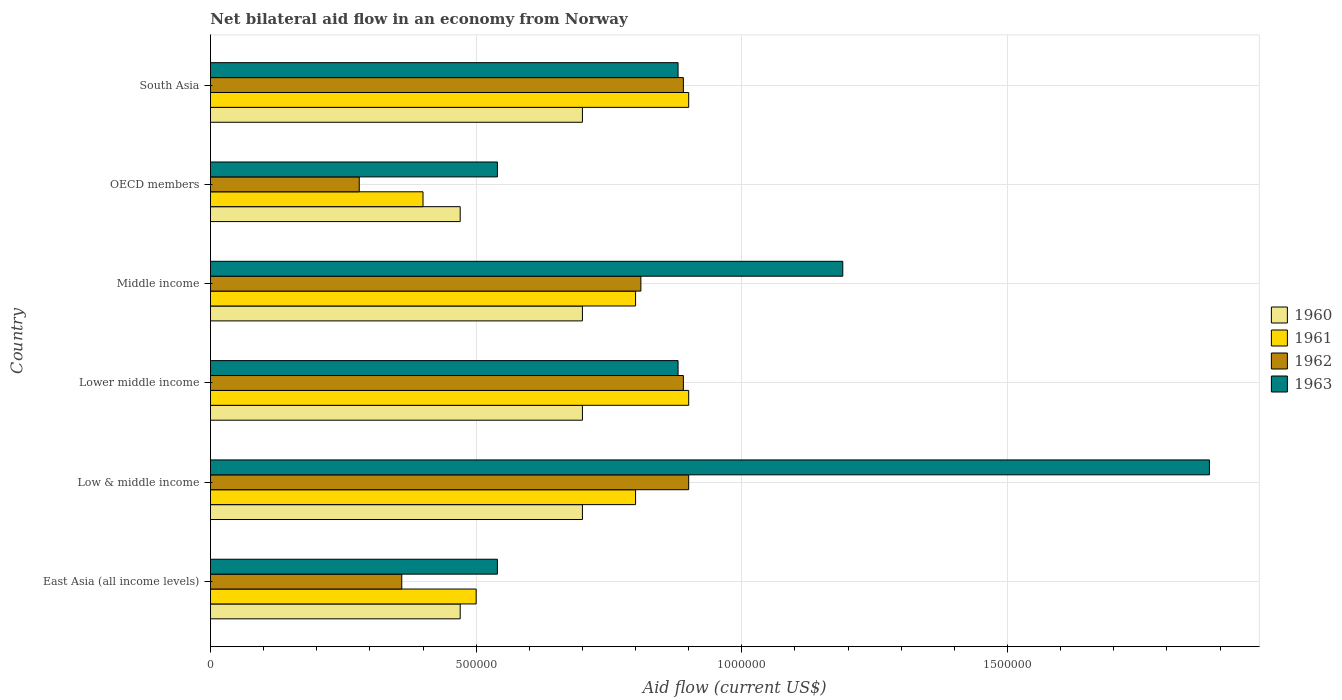How many groups of bars are there?
Offer a very short reply. 6. Are the number of bars on each tick of the Y-axis equal?
Provide a succinct answer. Yes. How many bars are there on the 2nd tick from the top?
Your response must be concise. 4. What is the label of the 4th group of bars from the top?
Your answer should be very brief. Lower middle income. What is the net bilateral aid flow in 1960 in OECD members?
Give a very brief answer. 4.70e+05. In which country was the net bilateral aid flow in 1960 minimum?
Your answer should be very brief. East Asia (all income levels). What is the total net bilateral aid flow in 1962 in the graph?
Offer a very short reply. 4.13e+06. What is the difference between the net bilateral aid flow in 1963 in South Asia and the net bilateral aid flow in 1962 in OECD members?
Offer a very short reply. 6.00e+05. What is the average net bilateral aid flow in 1961 per country?
Ensure brevity in your answer.  7.17e+05. What is the difference between the net bilateral aid flow in 1962 and net bilateral aid flow in 1961 in South Asia?
Ensure brevity in your answer.  -10000. In how many countries, is the net bilateral aid flow in 1960 greater than 800000 US$?
Keep it short and to the point. 0. What is the ratio of the net bilateral aid flow in 1962 in East Asia (all income levels) to that in OECD members?
Ensure brevity in your answer.  1.29. Is the net bilateral aid flow in 1961 in Middle income less than that in OECD members?
Offer a very short reply. No. Is the difference between the net bilateral aid flow in 1962 in Low & middle income and Middle income greater than the difference between the net bilateral aid flow in 1961 in Low & middle income and Middle income?
Give a very brief answer. Yes. What is the difference between the highest and the lowest net bilateral aid flow in 1961?
Give a very brief answer. 5.00e+05. Is the sum of the net bilateral aid flow in 1962 in Middle income and OECD members greater than the maximum net bilateral aid flow in 1960 across all countries?
Offer a very short reply. Yes. Is it the case that in every country, the sum of the net bilateral aid flow in 1960 and net bilateral aid flow in 1963 is greater than the sum of net bilateral aid flow in 1962 and net bilateral aid flow in 1961?
Keep it short and to the point. No. How many bars are there?
Provide a succinct answer. 24. Are all the bars in the graph horizontal?
Give a very brief answer. Yes. What is the difference between two consecutive major ticks on the X-axis?
Keep it short and to the point. 5.00e+05. Are the values on the major ticks of X-axis written in scientific E-notation?
Your response must be concise. No. Does the graph contain grids?
Offer a terse response. Yes. Where does the legend appear in the graph?
Offer a terse response. Center right. What is the title of the graph?
Provide a succinct answer. Net bilateral aid flow in an economy from Norway. Does "1966" appear as one of the legend labels in the graph?
Offer a terse response. No. What is the label or title of the X-axis?
Offer a very short reply. Aid flow (current US$). What is the Aid flow (current US$) in 1960 in East Asia (all income levels)?
Keep it short and to the point. 4.70e+05. What is the Aid flow (current US$) of 1961 in East Asia (all income levels)?
Ensure brevity in your answer.  5.00e+05. What is the Aid flow (current US$) in 1962 in East Asia (all income levels)?
Offer a very short reply. 3.60e+05. What is the Aid flow (current US$) in 1963 in East Asia (all income levels)?
Offer a very short reply. 5.40e+05. What is the Aid flow (current US$) of 1962 in Low & middle income?
Your answer should be very brief. 9.00e+05. What is the Aid flow (current US$) of 1963 in Low & middle income?
Give a very brief answer. 1.88e+06. What is the Aid flow (current US$) in 1962 in Lower middle income?
Offer a terse response. 8.90e+05. What is the Aid flow (current US$) in 1963 in Lower middle income?
Give a very brief answer. 8.80e+05. What is the Aid flow (current US$) of 1960 in Middle income?
Ensure brevity in your answer.  7.00e+05. What is the Aid flow (current US$) in 1962 in Middle income?
Keep it short and to the point. 8.10e+05. What is the Aid flow (current US$) in 1963 in Middle income?
Your response must be concise. 1.19e+06. What is the Aid flow (current US$) of 1960 in OECD members?
Offer a terse response. 4.70e+05. What is the Aid flow (current US$) of 1963 in OECD members?
Offer a terse response. 5.40e+05. What is the Aid flow (current US$) in 1960 in South Asia?
Ensure brevity in your answer.  7.00e+05. What is the Aid flow (current US$) in 1961 in South Asia?
Your response must be concise. 9.00e+05. What is the Aid flow (current US$) of 1962 in South Asia?
Give a very brief answer. 8.90e+05. What is the Aid flow (current US$) of 1963 in South Asia?
Your response must be concise. 8.80e+05. Across all countries, what is the maximum Aid flow (current US$) of 1962?
Ensure brevity in your answer.  9.00e+05. Across all countries, what is the maximum Aid flow (current US$) in 1963?
Your response must be concise. 1.88e+06. Across all countries, what is the minimum Aid flow (current US$) in 1960?
Provide a short and direct response. 4.70e+05. Across all countries, what is the minimum Aid flow (current US$) in 1961?
Make the answer very short. 4.00e+05. Across all countries, what is the minimum Aid flow (current US$) in 1962?
Ensure brevity in your answer.  2.80e+05. Across all countries, what is the minimum Aid flow (current US$) in 1963?
Offer a terse response. 5.40e+05. What is the total Aid flow (current US$) in 1960 in the graph?
Make the answer very short. 3.74e+06. What is the total Aid flow (current US$) of 1961 in the graph?
Make the answer very short. 4.30e+06. What is the total Aid flow (current US$) of 1962 in the graph?
Ensure brevity in your answer.  4.13e+06. What is the total Aid flow (current US$) in 1963 in the graph?
Your answer should be very brief. 5.91e+06. What is the difference between the Aid flow (current US$) in 1960 in East Asia (all income levels) and that in Low & middle income?
Offer a terse response. -2.30e+05. What is the difference between the Aid flow (current US$) of 1962 in East Asia (all income levels) and that in Low & middle income?
Your answer should be very brief. -5.40e+05. What is the difference between the Aid flow (current US$) of 1963 in East Asia (all income levels) and that in Low & middle income?
Ensure brevity in your answer.  -1.34e+06. What is the difference between the Aid flow (current US$) of 1961 in East Asia (all income levels) and that in Lower middle income?
Your answer should be compact. -4.00e+05. What is the difference between the Aid flow (current US$) of 1962 in East Asia (all income levels) and that in Lower middle income?
Make the answer very short. -5.30e+05. What is the difference between the Aid flow (current US$) of 1963 in East Asia (all income levels) and that in Lower middle income?
Keep it short and to the point. -3.40e+05. What is the difference between the Aid flow (current US$) in 1961 in East Asia (all income levels) and that in Middle income?
Provide a short and direct response. -3.00e+05. What is the difference between the Aid flow (current US$) of 1962 in East Asia (all income levels) and that in Middle income?
Ensure brevity in your answer.  -4.50e+05. What is the difference between the Aid flow (current US$) of 1963 in East Asia (all income levels) and that in Middle income?
Offer a terse response. -6.50e+05. What is the difference between the Aid flow (current US$) in 1961 in East Asia (all income levels) and that in OECD members?
Offer a terse response. 1.00e+05. What is the difference between the Aid flow (current US$) of 1962 in East Asia (all income levels) and that in OECD members?
Offer a terse response. 8.00e+04. What is the difference between the Aid flow (current US$) of 1961 in East Asia (all income levels) and that in South Asia?
Offer a terse response. -4.00e+05. What is the difference between the Aid flow (current US$) of 1962 in East Asia (all income levels) and that in South Asia?
Your answer should be compact. -5.30e+05. What is the difference between the Aid flow (current US$) of 1963 in East Asia (all income levels) and that in South Asia?
Provide a succinct answer. -3.40e+05. What is the difference between the Aid flow (current US$) in 1962 in Low & middle income and that in Lower middle income?
Offer a very short reply. 10000. What is the difference between the Aid flow (current US$) of 1962 in Low & middle income and that in Middle income?
Your answer should be very brief. 9.00e+04. What is the difference between the Aid flow (current US$) in 1963 in Low & middle income and that in Middle income?
Provide a succinct answer. 6.90e+05. What is the difference between the Aid flow (current US$) of 1960 in Low & middle income and that in OECD members?
Your response must be concise. 2.30e+05. What is the difference between the Aid flow (current US$) of 1961 in Low & middle income and that in OECD members?
Ensure brevity in your answer.  4.00e+05. What is the difference between the Aid flow (current US$) of 1962 in Low & middle income and that in OECD members?
Your answer should be very brief. 6.20e+05. What is the difference between the Aid flow (current US$) in 1963 in Low & middle income and that in OECD members?
Your response must be concise. 1.34e+06. What is the difference between the Aid flow (current US$) of 1963 in Low & middle income and that in South Asia?
Give a very brief answer. 1.00e+06. What is the difference between the Aid flow (current US$) of 1960 in Lower middle income and that in Middle income?
Your answer should be compact. 0. What is the difference between the Aid flow (current US$) of 1961 in Lower middle income and that in Middle income?
Offer a very short reply. 1.00e+05. What is the difference between the Aid flow (current US$) of 1962 in Lower middle income and that in Middle income?
Your answer should be very brief. 8.00e+04. What is the difference between the Aid flow (current US$) of 1963 in Lower middle income and that in Middle income?
Make the answer very short. -3.10e+05. What is the difference between the Aid flow (current US$) in 1963 in Lower middle income and that in South Asia?
Ensure brevity in your answer.  0. What is the difference between the Aid flow (current US$) in 1960 in Middle income and that in OECD members?
Give a very brief answer. 2.30e+05. What is the difference between the Aid flow (current US$) in 1962 in Middle income and that in OECD members?
Your response must be concise. 5.30e+05. What is the difference between the Aid flow (current US$) in 1963 in Middle income and that in OECD members?
Make the answer very short. 6.50e+05. What is the difference between the Aid flow (current US$) in 1961 in Middle income and that in South Asia?
Offer a very short reply. -1.00e+05. What is the difference between the Aid flow (current US$) in 1962 in Middle income and that in South Asia?
Provide a succinct answer. -8.00e+04. What is the difference between the Aid flow (current US$) in 1960 in OECD members and that in South Asia?
Make the answer very short. -2.30e+05. What is the difference between the Aid flow (current US$) in 1961 in OECD members and that in South Asia?
Make the answer very short. -5.00e+05. What is the difference between the Aid flow (current US$) of 1962 in OECD members and that in South Asia?
Offer a very short reply. -6.10e+05. What is the difference between the Aid flow (current US$) in 1963 in OECD members and that in South Asia?
Offer a terse response. -3.40e+05. What is the difference between the Aid flow (current US$) in 1960 in East Asia (all income levels) and the Aid flow (current US$) in 1961 in Low & middle income?
Make the answer very short. -3.30e+05. What is the difference between the Aid flow (current US$) of 1960 in East Asia (all income levels) and the Aid flow (current US$) of 1962 in Low & middle income?
Offer a very short reply. -4.30e+05. What is the difference between the Aid flow (current US$) in 1960 in East Asia (all income levels) and the Aid flow (current US$) in 1963 in Low & middle income?
Ensure brevity in your answer.  -1.41e+06. What is the difference between the Aid flow (current US$) in 1961 in East Asia (all income levels) and the Aid flow (current US$) in 1962 in Low & middle income?
Offer a very short reply. -4.00e+05. What is the difference between the Aid flow (current US$) in 1961 in East Asia (all income levels) and the Aid flow (current US$) in 1963 in Low & middle income?
Offer a terse response. -1.38e+06. What is the difference between the Aid flow (current US$) of 1962 in East Asia (all income levels) and the Aid flow (current US$) of 1963 in Low & middle income?
Offer a terse response. -1.52e+06. What is the difference between the Aid flow (current US$) of 1960 in East Asia (all income levels) and the Aid flow (current US$) of 1961 in Lower middle income?
Provide a succinct answer. -4.30e+05. What is the difference between the Aid flow (current US$) of 1960 in East Asia (all income levels) and the Aid flow (current US$) of 1962 in Lower middle income?
Ensure brevity in your answer.  -4.20e+05. What is the difference between the Aid flow (current US$) in 1960 in East Asia (all income levels) and the Aid flow (current US$) in 1963 in Lower middle income?
Keep it short and to the point. -4.10e+05. What is the difference between the Aid flow (current US$) of 1961 in East Asia (all income levels) and the Aid flow (current US$) of 1962 in Lower middle income?
Your response must be concise. -3.90e+05. What is the difference between the Aid flow (current US$) in 1961 in East Asia (all income levels) and the Aid flow (current US$) in 1963 in Lower middle income?
Give a very brief answer. -3.80e+05. What is the difference between the Aid flow (current US$) of 1962 in East Asia (all income levels) and the Aid flow (current US$) of 1963 in Lower middle income?
Provide a short and direct response. -5.20e+05. What is the difference between the Aid flow (current US$) of 1960 in East Asia (all income levels) and the Aid flow (current US$) of 1961 in Middle income?
Offer a very short reply. -3.30e+05. What is the difference between the Aid flow (current US$) of 1960 in East Asia (all income levels) and the Aid flow (current US$) of 1962 in Middle income?
Ensure brevity in your answer.  -3.40e+05. What is the difference between the Aid flow (current US$) in 1960 in East Asia (all income levels) and the Aid flow (current US$) in 1963 in Middle income?
Offer a very short reply. -7.20e+05. What is the difference between the Aid flow (current US$) in 1961 in East Asia (all income levels) and the Aid flow (current US$) in 1962 in Middle income?
Give a very brief answer. -3.10e+05. What is the difference between the Aid flow (current US$) in 1961 in East Asia (all income levels) and the Aid flow (current US$) in 1963 in Middle income?
Provide a short and direct response. -6.90e+05. What is the difference between the Aid flow (current US$) of 1962 in East Asia (all income levels) and the Aid flow (current US$) of 1963 in Middle income?
Offer a very short reply. -8.30e+05. What is the difference between the Aid flow (current US$) of 1960 in East Asia (all income levels) and the Aid flow (current US$) of 1963 in OECD members?
Give a very brief answer. -7.00e+04. What is the difference between the Aid flow (current US$) in 1961 in East Asia (all income levels) and the Aid flow (current US$) in 1962 in OECD members?
Offer a terse response. 2.20e+05. What is the difference between the Aid flow (current US$) in 1961 in East Asia (all income levels) and the Aid flow (current US$) in 1963 in OECD members?
Provide a succinct answer. -4.00e+04. What is the difference between the Aid flow (current US$) in 1960 in East Asia (all income levels) and the Aid flow (current US$) in 1961 in South Asia?
Keep it short and to the point. -4.30e+05. What is the difference between the Aid flow (current US$) of 1960 in East Asia (all income levels) and the Aid flow (current US$) of 1962 in South Asia?
Provide a short and direct response. -4.20e+05. What is the difference between the Aid flow (current US$) of 1960 in East Asia (all income levels) and the Aid flow (current US$) of 1963 in South Asia?
Give a very brief answer. -4.10e+05. What is the difference between the Aid flow (current US$) of 1961 in East Asia (all income levels) and the Aid flow (current US$) of 1962 in South Asia?
Keep it short and to the point. -3.90e+05. What is the difference between the Aid flow (current US$) of 1961 in East Asia (all income levels) and the Aid flow (current US$) of 1963 in South Asia?
Ensure brevity in your answer.  -3.80e+05. What is the difference between the Aid flow (current US$) in 1962 in East Asia (all income levels) and the Aid flow (current US$) in 1963 in South Asia?
Ensure brevity in your answer.  -5.20e+05. What is the difference between the Aid flow (current US$) in 1960 in Low & middle income and the Aid flow (current US$) in 1961 in Lower middle income?
Your answer should be compact. -2.00e+05. What is the difference between the Aid flow (current US$) of 1960 in Low & middle income and the Aid flow (current US$) of 1962 in Lower middle income?
Keep it short and to the point. -1.90e+05. What is the difference between the Aid flow (current US$) in 1960 in Low & middle income and the Aid flow (current US$) in 1963 in Lower middle income?
Your answer should be compact. -1.80e+05. What is the difference between the Aid flow (current US$) of 1961 in Low & middle income and the Aid flow (current US$) of 1962 in Lower middle income?
Keep it short and to the point. -9.00e+04. What is the difference between the Aid flow (current US$) in 1961 in Low & middle income and the Aid flow (current US$) in 1963 in Lower middle income?
Provide a short and direct response. -8.00e+04. What is the difference between the Aid flow (current US$) in 1960 in Low & middle income and the Aid flow (current US$) in 1962 in Middle income?
Make the answer very short. -1.10e+05. What is the difference between the Aid flow (current US$) in 1960 in Low & middle income and the Aid flow (current US$) in 1963 in Middle income?
Provide a succinct answer. -4.90e+05. What is the difference between the Aid flow (current US$) in 1961 in Low & middle income and the Aid flow (current US$) in 1963 in Middle income?
Provide a succinct answer. -3.90e+05. What is the difference between the Aid flow (current US$) in 1962 in Low & middle income and the Aid flow (current US$) in 1963 in Middle income?
Offer a very short reply. -2.90e+05. What is the difference between the Aid flow (current US$) of 1960 in Low & middle income and the Aid flow (current US$) of 1961 in OECD members?
Keep it short and to the point. 3.00e+05. What is the difference between the Aid flow (current US$) in 1960 in Low & middle income and the Aid flow (current US$) in 1963 in OECD members?
Give a very brief answer. 1.60e+05. What is the difference between the Aid flow (current US$) of 1961 in Low & middle income and the Aid flow (current US$) of 1962 in OECD members?
Your answer should be very brief. 5.20e+05. What is the difference between the Aid flow (current US$) of 1960 in Low & middle income and the Aid flow (current US$) of 1961 in South Asia?
Make the answer very short. -2.00e+05. What is the difference between the Aid flow (current US$) in 1961 in Low & middle income and the Aid flow (current US$) in 1962 in South Asia?
Provide a succinct answer. -9.00e+04. What is the difference between the Aid flow (current US$) in 1961 in Low & middle income and the Aid flow (current US$) in 1963 in South Asia?
Your answer should be compact. -8.00e+04. What is the difference between the Aid flow (current US$) of 1962 in Low & middle income and the Aid flow (current US$) of 1963 in South Asia?
Provide a short and direct response. 2.00e+04. What is the difference between the Aid flow (current US$) of 1960 in Lower middle income and the Aid flow (current US$) of 1961 in Middle income?
Provide a succinct answer. -1.00e+05. What is the difference between the Aid flow (current US$) in 1960 in Lower middle income and the Aid flow (current US$) in 1962 in Middle income?
Your answer should be compact. -1.10e+05. What is the difference between the Aid flow (current US$) of 1960 in Lower middle income and the Aid flow (current US$) of 1963 in Middle income?
Offer a very short reply. -4.90e+05. What is the difference between the Aid flow (current US$) in 1961 in Lower middle income and the Aid flow (current US$) in 1962 in Middle income?
Your answer should be compact. 9.00e+04. What is the difference between the Aid flow (current US$) of 1960 in Lower middle income and the Aid flow (current US$) of 1961 in OECD members?
Your answer should be very brief. 3.00e+05. What is the difference between the Aid flow (current US$) of 1960 in Lower middle income and the Aid flow (current US$) of 1963 in OECD members?
Keep it short and to the point. 1.60e+05. What is the difference between the Aid flow (current US$) of 1961 in Lower middle income and the Aid flow (current US$) of 1962 in OECD members?
Offer a very short reply. 6.20e+05. What is the difference between the Aid flow (current US$) in 1961 in Lower middle income and the Aid flow (current US$) in 1963 in OECD members?
Offer a very short reply. 3.60e+05. What is the difference between the Aid flow (current US$) in 1962 in Lower middle income and the Aid flow (current US$) in 1963 in OECD members?
Keep it short and to the point. 3.50e+05. What is the difference between the Aid flow (current US$) in 1960 in Lower middle income and the Aid flow (current US$) in 1963 in South Asia?
Make the answer very short. -1.80e+05. What is the difference between the Aid flow (current US$) in 1960 in Middle income and the Aid flow (current US$) in 1963 in OECD members?
Your response must be concise. 1.60e+05. What is the difference between the Aid flow (current US$) of 1961 in Middle income and the Aid flow (current US$) of 1962 in OECD members?
Your response must be concise. 5.20e+05. What is the difference between the Aid flow (current US$) in 1962 in Middle income and the Aid flow (current US$) in 1963 in South Asia?
Make the answer very short. -7.00e+04. What is the difference between the Aid flow (current US$) of 1960 in OECD members and the Aid flow (current US$) of 1961 in South Asia?
Provide a short and direct response. -4.30e+05. What is the difference between the Aid flow (current US$) of 1960 in OECD members and the Aid flow (current US$) of 1962 in South Asia?
Give a very brief answer. -4.20e+05. What is the difference between the Aid flow (current US$) in 1960 in OECD members and the Aid flow (current US$) in 1963 in South Asia?
Ensure brevity in your answer.  -4.10e+05. What is the difference between the Aid flow (current US$) in 1961 in OECD members and the Aid flow (current US$) in 1962 in South Asia?
Offer a terse response. -4.90e+05. What is the difference between the Aid flow (current US$) in 1961 in OECD members and the Aid flow (current US$) in 1963 in South Asia?
Your answer should be compact. -4.80e+05. What is the difference between the Aid flow (current US$) of 1962 in OECD members and the Aid flow (current US$) of 1963 in South Asia?
Ensure brevity in your answer.  -6.00e+05. What is the average Aid flow (current US$) of 1960 per country?
Provide a succinct answer. 6.23e+05. What is the average Aid flow (current US$) of 1961 per country?
Your answer should be compact. 7.17e+05. What is the average Aid flow (current US$) of 1962 per country?
Your answer should be compact. 6.88e+05. What is the average Aid flow (current US$) of 1963 per country?
Your response must be concise. 9.85e+05. What is the difference between the Aid flow (current US$) in 1961 and Aid flow (current US$) in 1963 in East Asia (all income levels)?
Your answer should be compact. -4.00e+04. What is the difference between the Aid flow (current US$) of 1962 and Aid flow (current US$) of 1963 in East Asia (all income levels)?
Your answer should be very brief. -1.80e+05. What is the difference between the Aid flow (current US$) of 1960 and Aid flow (current US$) of 1963 in Low & middle income?
Your answer should be very brief. -1.18e+06. What is the difference between the Aid flow (current US$) of 1961 and Aid flow (current US$) of 1963 in Low & middle income?
Give a very brief answer. -1.08e+06. What is the difference between the Aid flow (current US$) of 1962 and Aid flow (current US$) of 1963 in Low & middle income?
Provide a succinct answer. -9.80e+05. What is the difference between the Aid flow (current US$) in 1960 and Aid flow (current US$) in 1961 in Lower middle income?
Offer a terse response. -2.00e+05. What is the difference between the Aid flow (current US$) of 1960 and Aid flow (current US$) of 1962 in Lower middle income?
Your response must be concise. -1.90e+05. What is the difference between the Aid flow (current US$) in 1961 and Aid flow (current US$) in 1963 in Lower middle income?
Make the answer very short. 2.00e+04. What is the difference between the Aid flow (current US$) in 1960 and Aid flow (current US$) in 1963 in Middle income?
Your answer should be very brief. -4.90e+05. What is the difference between the Aid flow (current US$) in 1961 and Aid flow (current US$) in 1963 in Middle income?
Your response must be concise. -3.90e+05. What is the difference between the Aid flow (current US$) in 1962 and Aid flow (current US$) in 1963 in Middle income?
Your answer should be very brief. -3.80e+05. What is the difference between the Aid flow (current US$) in 1960 and Aid flow (current US$) in 1961 in OECD members?
Give a very brief answer. 7.00e+04. What is the difference between the Aid flow (current US$) of 1960 and Aid flow (current US$) of 1963 in OECD members?
Offer a terse response. -7.00e+04. What is the difference between the Aid flow (current US$) of 1961 and Aid flow (current US$) of 1962 in OECD members?
Ensure brevity in your answer.  1.20e+05. What is the difference between the Aid flow (current US$) in 1962 and Aid flow (current US$) in 1963 in OECD members?
Provide a succinct answer. -2.60e+05. What is the difference between the Aid flow (current US$) in 1960 and Aid flow (current US$) in 1962 in South Asia?
Your answer should be compact. -1.90e+05. What is the difference between the Aid flow (current US$) in 1960 and Aid flow (current US$) in 1963 in South Asia?
Your answer should be very brief. -1.80e+05. What is the difference between the Aid flow (current US$) in 1961 and Aid flow (current US$) in 1962 in South Asia?
Ensure brevity in your answer.  10000. What is the difference between the Aid flow (current US$) of 1962 and Aid flow (current US$) of 1963 in South Asia?
Offer a very short reply. 10000. What is the ratio of the Aid flow (current US$) of 1960 in East Asia (all income levels) to that in Low & middle income?
Your answer should be very brief. 0.67. What is the ratio of the Aid flow (current US$) of 1963 in East Asia (all income levels) to that in Low & middle income?
Make the answer very short. 0.29. What is the ratio of the Aid flow (current US$) of 1960 in East Asia (all income levels) to that in Lower middle income?
Your answer should be very brief. 0.67. What is the ratio of the Aid flow (current US$) in 1961 in East Asia (all income levels) to that in Lower middle income?
Keep it short and to the point. 0.56. What is the ratio of the Aid flow (current US$) in 1962 in East Asia (all income levels) to that in Lower middle income?
Offer a terse response. 0.4. What is the ratio of the Aid flow (current US$) in 1963 in East Asia (all income levels) to that in Lower middle income?
Your response must be concise. 0.61. What is the ratio of the Aid flow (current US$) of 1960 in East Asia (all income levels) to that in Middle income?
Your answer should be very brief. 0.67. What is the ratio of the Aid flow (current US$) in 1962 in East Asia (all income levels) to that in Middle income?
Ensure brevity in your answer.  0.44. What is the ratio of the Aid flow (current US$) in 1963 in East Asia (all income levels) to that in Middle income?
Ensure brevity in your answer.  0.45. What is the ratio of the Aid flow (current US$) of 1960 in East Asia (all income levels) to that in OECD members?
Make the answer very short. 1. What is the ratio of the Aid flow (current US$) in 1960 in East Asia (all income levels) to that in South Asia?
Your response must be concise. 0.67. What is the ratio of the Aid flow (current US$) in 1961 in East Asia (all income levels) to that in South Asia?
Provide a short and direct response. 0.56. What is the ratio of the Aid flow (current US$) of 1962 in East Asia (all income levels) to that in South Asia?
Ensure brevity in your answer.  0.4. What is the ratio of the Aid flow (current US$) in 1963 in East Asia (all income levels) to that in South Asia?
Your response must be concise. 0.61. What is the ratio of the Aid flow (current US$) in 1960 in Low & middle income to that in Lower middle income?
Give a very brief answer. 1. What is the ratio of the Aid flow (current US$) in 1961 in Low & middle income to that in Lower middle income?
Make the answer very short. 0.89. What is the ratio of the Aid flow (current US$) in 1962 in Low & middle income to that in Lower middle income?
Offer a terse response. 1.01. What is the ratio of the Aid flow (current US$) of 1963 in Low & middle income to that in Lower middle income?
Your answer should be compact. 2.14. What is the ratio of the Aid flow (current US$) of 1960 in Low & middle income to that in Middle income?
Ensure brevity in your answer.  1. What is the ratio of the Aid flow (current US$) of 1961 in Low & middle income to that in Middle income?
Offer a very short reply. 1. What is the ratio of the Aid flow (current US$) in 1963 in Low & middle income to that in Middle income?
Offer a terse response. 1.58. What is the ratio of the Aid flow (current US$) of 1960 in Low & middle income to that in OECD members?
Your answer should be very brief. 1.49. What is the ratio of the Aid flow (current US$) of 1962 in Low & middle income to that in OECD members?
Your answer should be compact. 3.21. What is the ratio of the Aid flow (current US$) in 1963 in Low & middle income to that in OECD members?
Keep it short and to the point. 3.48. What is the ratio of the Aid flow (current US$) in 1960 in Low & middle income to that in South Asia?
Offer a terse response. 1. What is the ratio of the Aid flow (current US$) in 1962 in Low & middle income to that in South Asia?
Make the answer very short. 1.01. What is the ratio of the Aid flow (current US$) in 1963 in Low & middle income to that in South Asia?
Your answer should be compact. 2.14. What is the ratio of the Aid flow (current US$) of 1960 in Lower middle income to that in Middle income?
Offer a very short reply. 1. What is the ratio of the Aid flow (current US$) of 1961 in Lower middle income to that in Middle income?
Your response must be concise. 1.12. What is the ratio of the Aid flow (current US$) in 1962 in Lower middle income to that in Middle income?
Your response must be concise. 1.1. What is the ratio of the Aid flow (current US$) in 1963 in Lower middle income to that in Middle income?
Ensure brevity in your answer.  0.74. What is the ratio of the Aid flow (current US$) of 1960 in Lower middle income to that in OECD members?
Your answer should be compact. 1.49. What is the ratio of the Aid flow (current US$) in 1961 in Lower middle income to that in OECD members?
Your answer should be compact. 2.25. What is the ratio of the Aid flow (current US$) of 1962 in Lower middle income to that in OECD members?
Provide a short and direct response. 3.18. What is the ratio of the Aid flow (current US$) of 1963 in Lower middle income to that in OECD members?
Provide a succinct answer. 1.63. What is the ratio of the Aid flow (current US$) of 1960 in Lower middle income to that in South Asia?
Ensure brevity in your answer.  1. What is the ratio of the Aid flow (current US$) of 1962 in Lower middle income to that in South Asia?
Ensure brevity in your answer.  1. What is the ratio of the Aid flow (current US$) in 1960 in Middle income to that in OECD members?
Your response must be concise. 1.49. What is the ratio of the Aid flow (current US$) of 1962 in Middle income to that in OECD members?
Offer a very short reply. 2.89. What is the ratio of the Aid flow (current US$) in 1963 in Middle income to that in OECD members?
Keep it short and to the point. 2.2. What is the ratio of the Aid flow (current US$) of 1960 in Middle income to that in South Asia?
Provide a short and direct response. 1. What is the ratio of the Aid flow (current US$) of 1962 in Middle income to that in South Asia?
Make the answer very short. 0.91. What is the ratio of the Aid flow (current US$) of 1963 in Middle income to that in South Asia?
Make the answer very short. 1.35. What is the ratio of the Aid flow (current US$) of 1960 in OECD members to that in South Asia?
Offer a terse response. 0.67. What is the ratio of the Aid flow (current US$) of 1961 in OECD members to that in South Asia?
Provide a short and direct response. 0.44. What is the ratio of the Aid flow (current US$) in 1962 in OECD members to that in South Asia?
Offer a very short reply. 0.31. What is the ratio of the Aid flow (current US$) of 1963 in OECD members to that in South Asia?
Your answer should be very brief. 0.61. What is the difference between the highest and the second highest Aid flow (current US$) in 1960?
Keep it short and to the point. 0. What is the difference between the highest and the second highest Aid flow (current US$) of 1961?
Give a very brief answer. 0. What is the difference between the highest and the second highest Aid flow (current US$) in 1962?
Your answer should be compact. 10000. What is the difference between the highest and the second highest Aid flow (current US$) in 1963?
Keep it short and to the point. 6.90e+05. What is the difference between the highest and the lowest Aid flow (current US$) in 1961?
Your answer should be very brief. 5.00e+05. What is the difference between the highest and the lowest Aid flow (current US$) of 1962?
Offer a terse response. 6.20e+05. What is the difference between the highest and the lowest Aid flow (current US$) in 1963?
Your answer should be compact. 1.34e+06. 